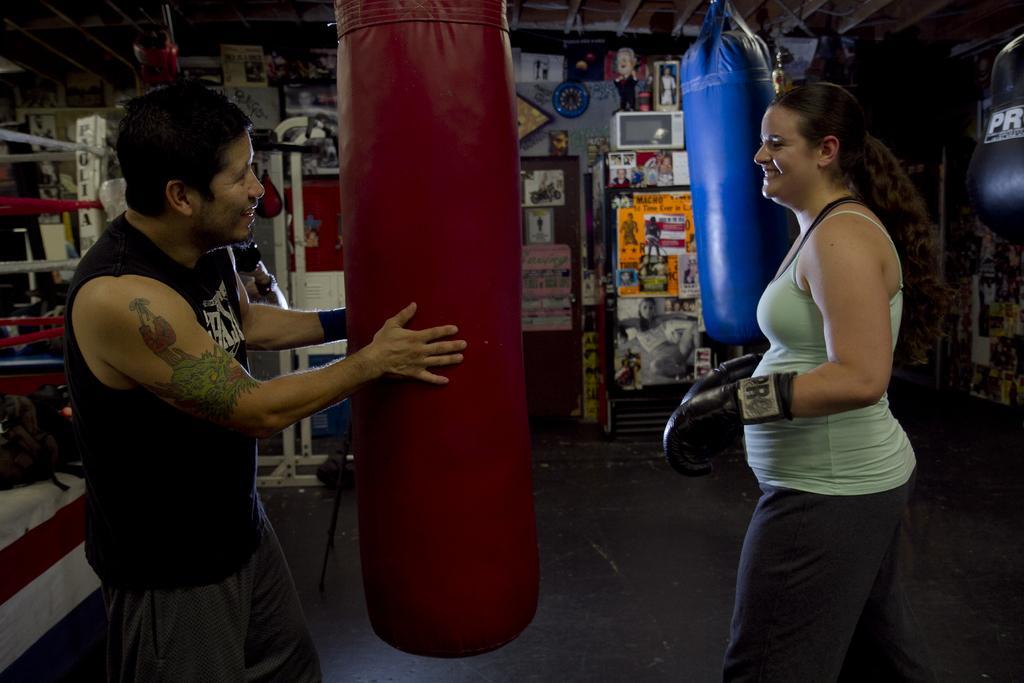Describe this image in one or two sentences. In the image there is a woman, she is wearing gloves and in front of the woman a man is holding a punching bag. Behind them there are many posters and objects kept in front of a wall. 